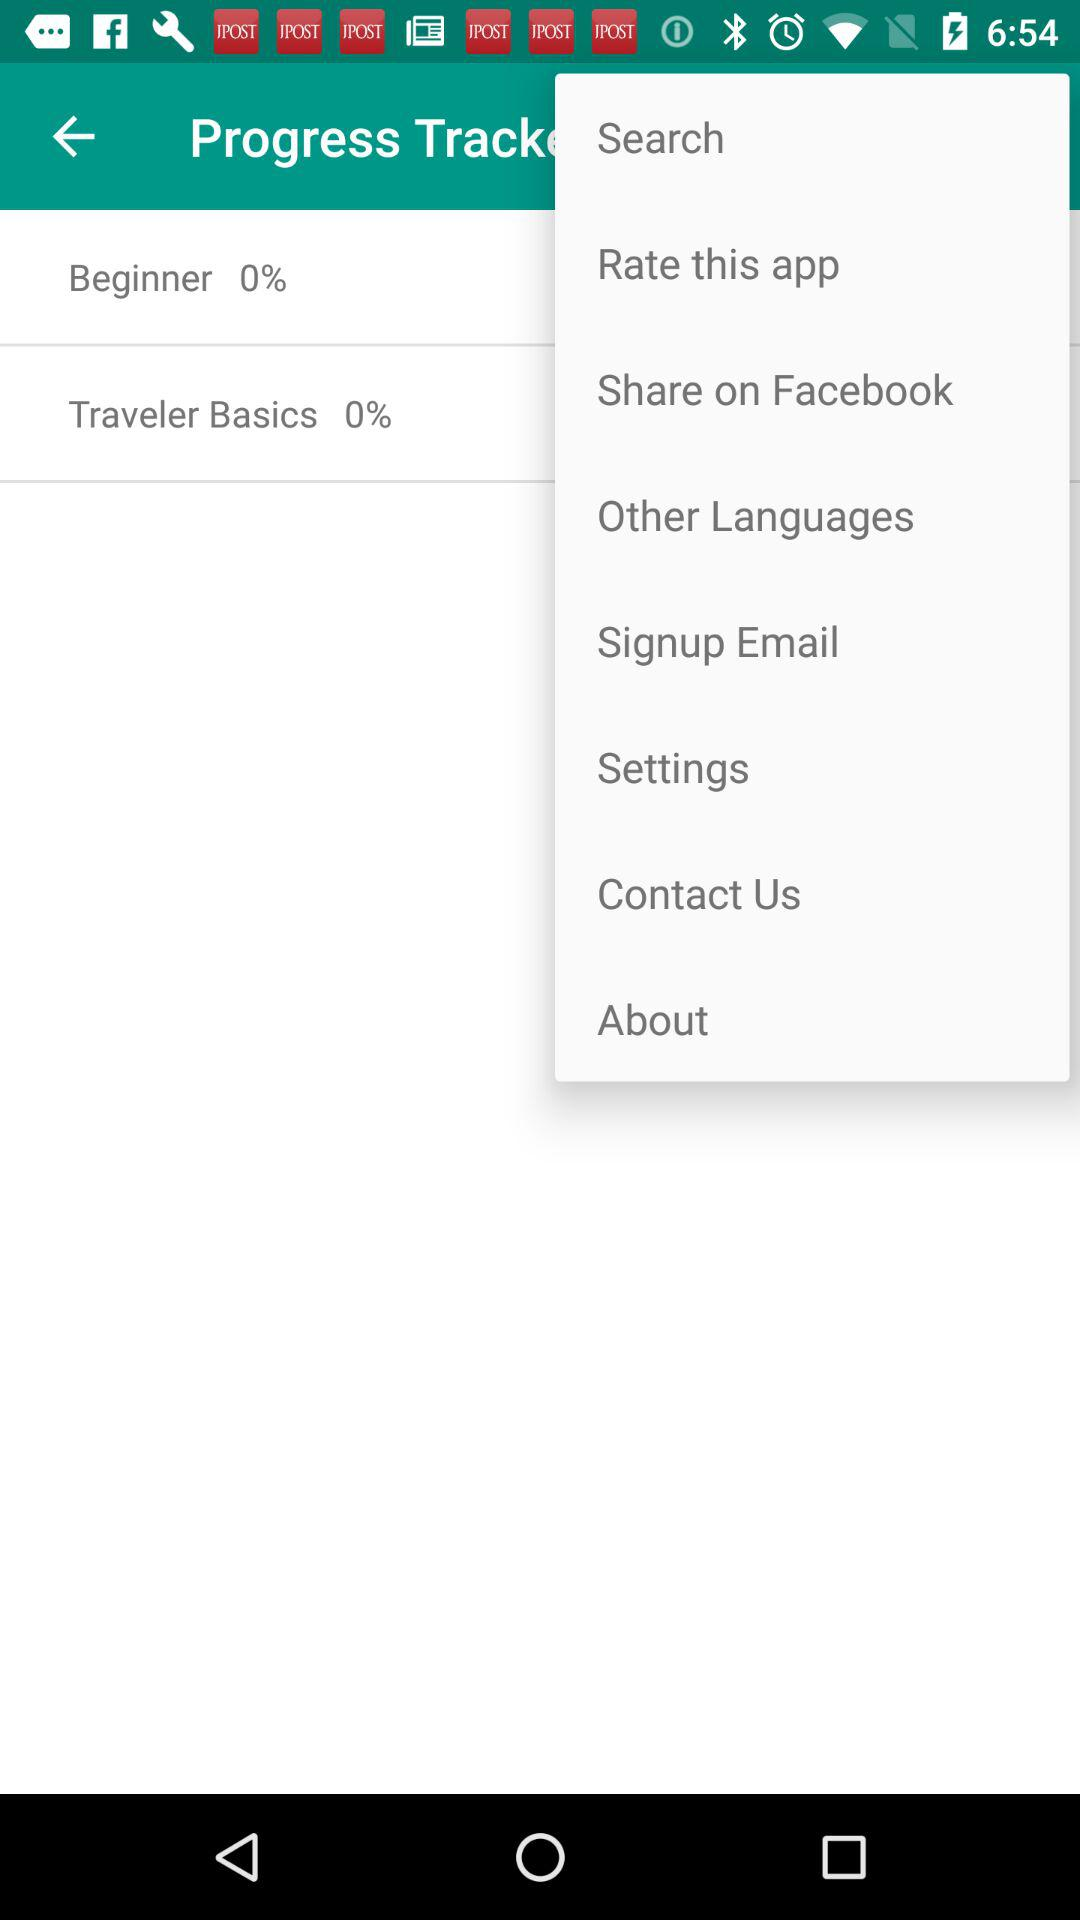What is the percentage of beginner? The percentage of beginner is 0. 